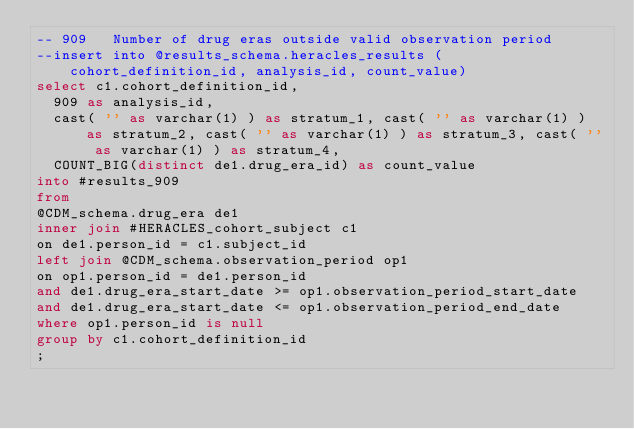Convert code to text. <code><loc_0><loc_0><loc_500><loc_500><_SQL_>-- 909   Number of drug eras outside valid observation period
--insert into @results_schema.heracles_results (cohort_definition_id, analysis_id, count_value)
select c1.cohort_definition_id,
  909 as analysis_id,
  cast( '' as varchar(1) ) as stratum_1, cast( '' as varchar(1) ) as stratum_2, cast( '' as varchar(1) ) as stratum_3, cast( '' as varchar(1) ) as stratum_4,
  COUNT_BIG(distinct de1.drug_era_id) as count_value
into #results_909
from
@CDM_schema.drug_era de1
inner join #HERACLES_cohort_subject c1
on de1.person_id = c1.subject_id
left join @CDM_schema.observation_period op1
on op1.person_id = de1.person_id
and de1.drug_era_start_date >= op1.observation_period_start_date
and de1.drug_era_start_date <= op1.observation_period_end_date
where op1.person_id is null
group by c1.cohort_definition_id
;</code> 